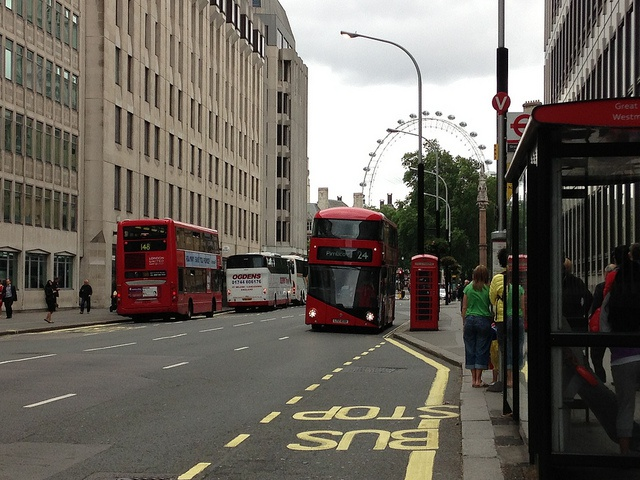Describe the objects in this image and their specific colors. I can see bus in gray, black, maroon, and brown tones, bus in gray, black, and maroon tones, people in gray, black, and maroon tones, bus in gray, black, and maroon tones, and people in gray, black, darkgreen, and maroon tones in this image. 